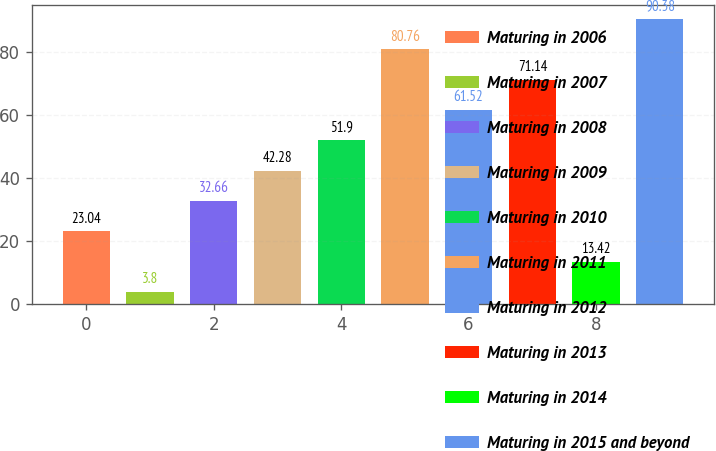<chart> <loc_0><loc_0><loc_500><loc_500><bar_chart><fcel>Maturing in 2006<fcel>Maturing in 2007<fcel>Maturing in 2008<fcel>Maturing in 2009<fcel>Maturing in 2010<fcel>Maturing in 2011<fcel>Maturing in 2012<fcel>Maturing in 2013<fcel>Maturing in 2014<fcel>Maturing in 2015 and beyond<nl><fcel>23.04<fcel>3.8<fcel>32.66<fcel>42.28<fcel>51.9<fcel>80.76<fcel>61.52<fcel>71.14<fcel>13.42<fcel>90.38<nl></chart> 